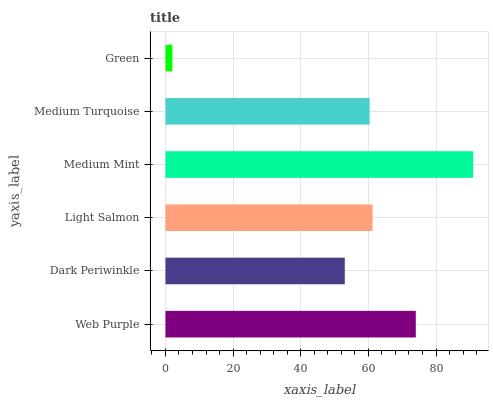Is Green the minimum?
Answer yes or no. Yes. Is Medium Mint the maximum?
Answer yes or no. Yes. Is Dark Periwinkle the minimum?
Answer yes or no. No. Is Dark Periwinkle the maximum?
Answer yes or no. No. Is Web Purple greater than Dark Periwinkle?
Answer yes or no. Yes. Is Dark Periwinkle less than Web Purple?
Answer yes or no. Yes. Is Dark Periwinkle greater than Web Purple?
Answer yes or no. No. Is Web Purple less than Dark Periwinkle?
Answer yes or no. No. Is Light Salmon the high median?
Answer yes or no. Yes. Is Medium Turquoise the low median?
Answer yes or no. Yes. Is Medium Mint the high median?
Answer yes or no. No. Is Light Salmon the low median?
Answer yes or no. No. 